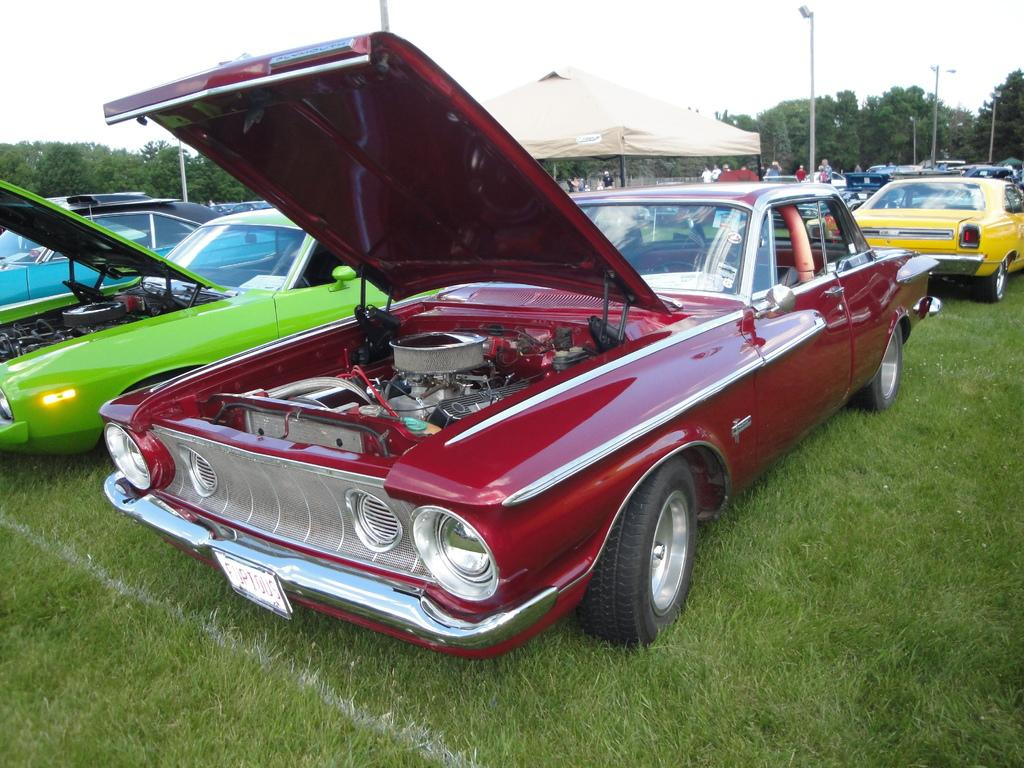What color is the car in the image? The car in the image is red. What is the position of the hood of the red car? The hood of the red car is open. Where is the red car located? The car is on a greenery ground. Are there any other cars in the image? Yes, there are other cars beside and behind the red car. What can be seen in the background of the image? There are trees and poles in the background of the image. How many pizzas are on the roof of the red car in the image? There are no pizzas present in the image, let alone on the roof of the red car. 